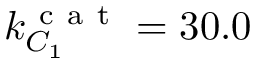<formula> <loc_0><loc_0><loc_500><loc_500>k _ { C _ { 1 } } ^ { c a t } = 3 0 . 0</formula> 